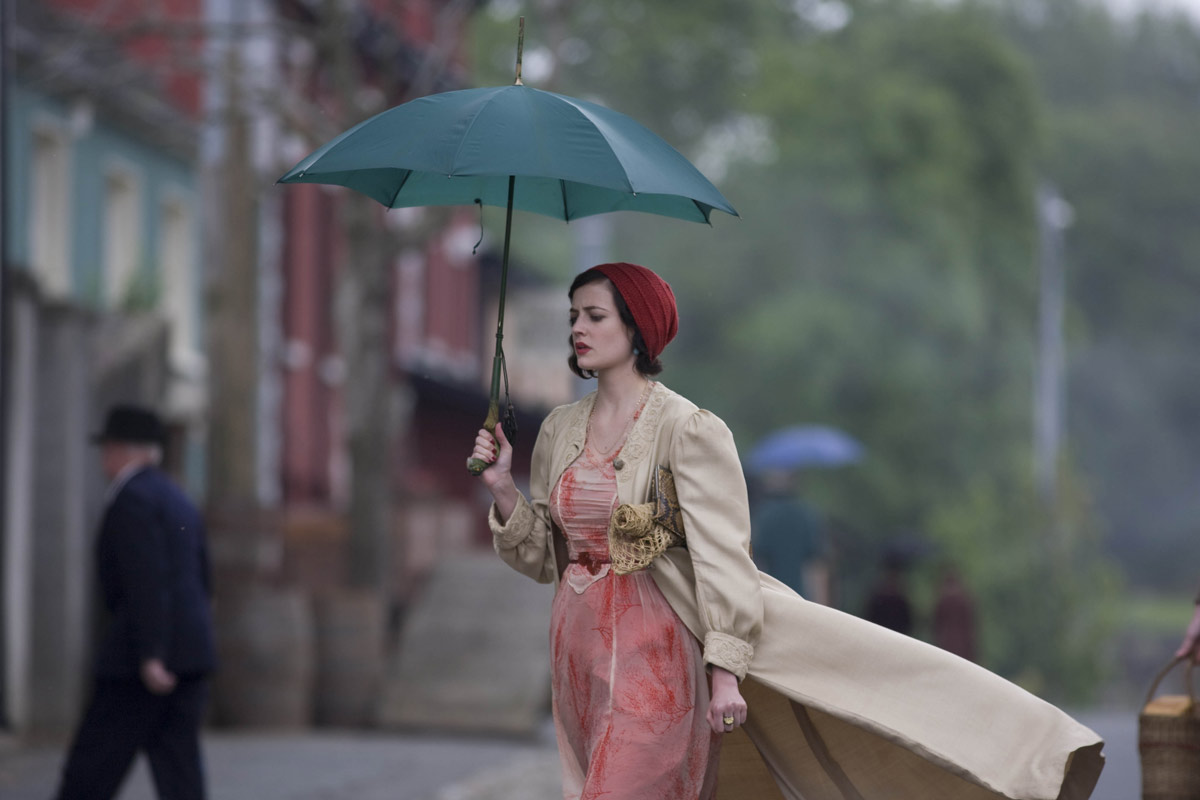What do you think is going on in this snapshot? This image depicts a woman walking alone down a cobblestone street while holding a green umbrella and wearing a long peach-colored dress, a red headscarf, and an overcoat. Her serious expression indicates she may be deep in thought or concerned about something. The backdrop includes a man wearing a top hat and a horse-drawn carriage, which suggest a historical or period setting, potentially conveying a scene from a drama or film focused on a bygone era. 